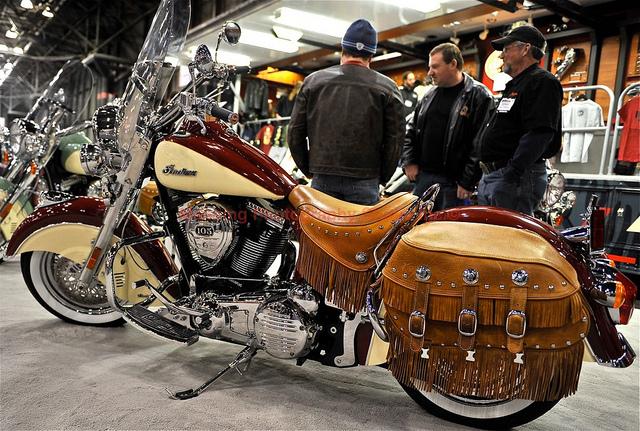How many men are visible?
Concise answer only. 3. What kind of vehicle is shown?
Write a very short answer. Motorcycle. What is the number on the engine?
Answer briefly. 105. 